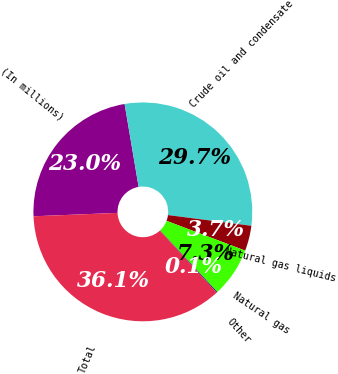<chart> <loc_0><loc_0><loc_500><loc_500><pie_chart><fcel>(In millions)<fcel>Crude oil and condensate<fcel>Natural gas liquids<fcel>Natural gas<fcel>Other<fcel>Total<nl><fcel>22.98%<fcel>29.7%<fcel>3.73%<fcel>7.33%<fcel>0.13%<fcel>36.14%<nl></chart> 